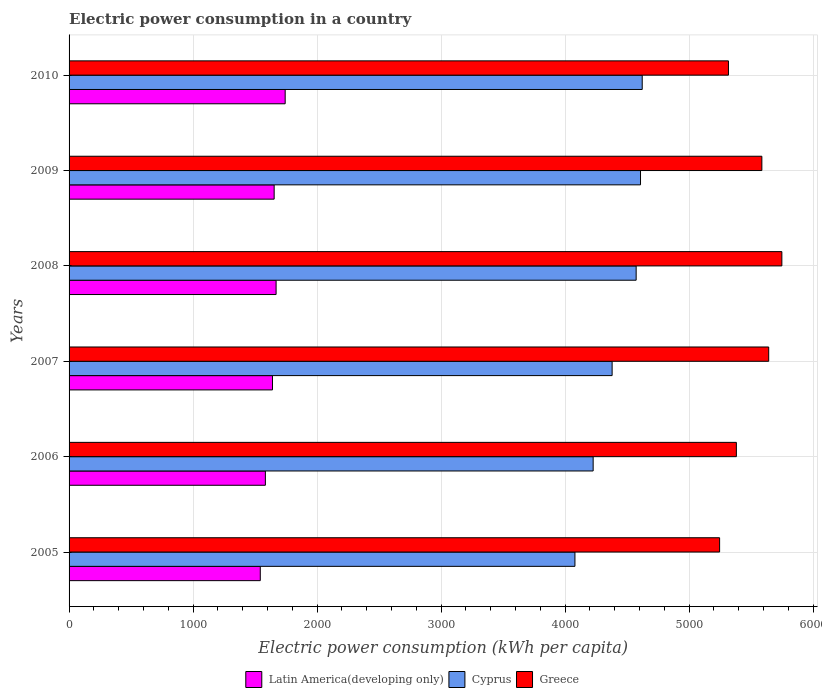How many groups of bars are there?
Your answer should be very brief. 6. Are the number of bars per tick equal to the number of legend labels?
Ensure brevity in your answer.  Yes. How many bars are there on the 5th tick from the top?
Your answer should be compact. 3. How many bars are there on the 6th tick from the bottom?
Give a very brief answer. 3. What is the electric power consumption in in Latin America(developing only) in 2010?
Your response must be concise. 1742.94. Across all years, what is the maximum electric power consumption in in Latin America(developing only)?
Offer a very short reply. 1742.94. Across all years, what is the minimum electric power consumption in in Cyprus?
Your answer should be compact. 4080.05. In which year was the electric power consumption in in Latin America(developing only) minimum?
Provide a succinct answer. 2005. What is the total electric power consumption in in Cyprus in the graph?
Offer a very short reply. 2.65e+04. What is the difference between the electric power consumption in in Latin America(developing only) in 2009 and that in 2010?
Provide a short and direct response. -88.87. What is the difference between the electric power consumption in in Cyprus in 2006 and the electric power consumption in in Greece in 2005?
Provide a short and direct response. -1019.9. What is the average electric power consumption in in Cyprus per year?
Your response must be concise. 4415.37. In the year 2007, what is the difference between the electric power consumption in in Cyprus and electric power consumption in in Latin America(developing only)?
Provide a succinct answer. 2739.26. What is the ratio of the electric power consumption in in Greece in 2007 to that in 2008?
Make the answer very short. 0.98. Is the electric power consumption in in Latin America(developing only) in 2005 less than that in 2006?
Ensure brevity in your answer.  Yes. What is the difference between the highest and the second highest electric power consumption in in Cyprus?
Provide a short and direct response. 13.74. What is the difference between the highest and the lowest electric power consumption in in Cyprus?
Provide a succinct answer. 542.65. In how many years, is the electric power consumption in in Cyprus greater than the average electric power consumption in in Cyprus taken over all years?
Provide a short and direct response. 3. What does the 3rd bar from the top in 2006 represents?
Your response must be concise. Latin America(developing only). What does the 2nd bar from the bottom in 2005 represents?
Provide a short and direct response. Cyprus. Is it the case that in every year, the sum of the electric power consumption in in Latin America(developing only) and electric power consumption in in Cyprus is greater than the electric power consumption in in Greece?
Keep it short and to the point. Yes. How many bars are there?
Provide a succinct answer. 18. Does the graph contain any zero values?
Make the answer very short. No. Does the graph contain grids?
Give a very brief answer. Yes. Where does the legend appear in the graph?
Offer a very short reply. Bottom center. How many legend labels are there?
Offer a very short reply. 3. What is the title of the graph?
Offer a very short reply. Electric power consumption in a country. Does "Lower middle income" appear as one of the legend labels in the graph?
Your answer should be compact. No. What is the label or title of the X-axis?
Ensure brevity in your answer.  Electric power consumption (kWh per capita). What is the label or title of the Y-axis?
Provide a short and direct response. Years. What is the Electric power consumption (kWh per capita) in Latin America(developing only) in 2005?
Provide a succinct answer. 1542.13. What is the Electric power consumption (kWh per capita) in Cyprus in 2005?
Your response must be concise. 4080.05. What is the Electric power consumption (kWh per capita) of Greece in 2005?
Provide a succinct answer. 5246.77. What is the Electric power consumption (kWh per capita) of Latin America(developing only) in 2006?
Keep it short and to the point. 1583.23. What is the Electric power consumption (kWh per capita) in Cyprus in 2006?
Provide a short and direct response. 4226.87. What is the Electric power consumption (kWh per capita) in Greece in 2006?
Provide a short and direct response. 5382.03. What is the Electric power consumption (kWh per capita) of Latin America(developing only) in 2007?
Offer a terse response. 1640.63. What is the Electric power consumption (kWh per capita) in Cyprus in 2007?
Ensure brevity in your answer.  4379.89. What is the Electric power consumption (kWh per capita) of Greece in 2007?
Your answer should be very brief. 5642.84. What is the Electric power consumption (kWh per capita) of Latin America(developing only) in 2008?
Make the answer very short. 1669.76. What is the Electric power consumption (kWh per capita) in Cyprus in 2008?
Your answer should be compact. 4573.77. What is the Electric power consumption (kWh per capita) of Greece in 2008?
Make the answer very short. 5748.84. What is the Electric power consumption (kWh per capita) of Latin America(developing only) in 2009?
Keep it short and to the point. 1654.08. What is the Electric power consumption (kWh per capita) in Cyprus in 2009?
Your response must be concise. 4608.95. What is the Electric power consumption (kWh per capita) of Greece in 2009?
Offer a very short reply. 5587.6. What is the Electric power consumption (kWh per capita) of Latin America(developing only) in 2010?
Offer a very short reply. 1742.94. What is the Electric power consumption (kWh per capita) in Cyprus in 2010?
Provide a short and direct response. 4622.7. What is the Electric power consumption (kWh per capita) of Greece in 2010?
Ensure brevity in your answer.  5318.08. Across all years, what is the maximum Electric power consumption (kWh per capita) of Latin America(developing only)?
Your answer should be very brief. 1742.94. Across all years, what is the maximum Electric power consumption (kWh per capita) in Cyprus?
Provide a short and direct response. 4622.7. Across all years, what is the maximum Electric power consumption (kWh per capita) in Greece?
Offer a terse response. 5748.84. Across all years, what is the minimum Electric power consumption (kWh per capita) in Latin America(developing only)?
Provide a succinct answer. 1542.13. Across all years, what is the minimum Electric power consumption (kWh per capita) in Cyprus?
Make the answer very short. 4080.05. Across all years, what is the minimum Electric power consumption (kWh per capita) in Greece?
Give a very brief answer. 5246.77. What is the total Electric power consumption (kWh per capita) in Latin America(developing only) in the graph?
Your answer should be compact. 9832.77. What is the total Electric power consumption (kWh per capita) in Cyprus in the graph?
Give a very brief answer. 2.65e+04. What is the total Electric power consumption (kWh per capita) in Greece in the graph?
Make the answer very short. 3.29e+04. What is the difference between the Electric power consumption (kWh per capita) in Latin America(developing only) in 2005 and that in 2006?
Provide a succinct answer. -41.1. What is the difference between the Electric power consumption (kWh per capita) of Cyprus in 2005 and that in 2006?
Your answer should be compact. -146.82. What is the difference between the Electric power consumption (kWh per capita) in Greece in 2005 and that in 2006?
Your answer should be very brief. -135.26. What is the difference between the Electric power consumption (kWh per capita) of Latin America(developing only) in 2005 and that in 2007?
Offer a very short reply. -98.51. What is the difference between the Electric power consumption (kWh per capita) of Cyprus in 2005 and that in 2007?
Give a very brief answer. -299.84. What is the difference between the Electric power consumption (kWh per capita) of Greece in 2005 and that in 2007?
Your answer should be compact. -396.06. What is the difference between the Electric power consumption (kWh per capita) of Latin America(developing only) in 2005 and that in 2008?
Ensure brevity in your answer.  -127.63. What is the difference between the Electric power consumption (kWh per capita) of Cyprus in 2005 and that in 2008?
Keep it short and to the point. -493.73. What is the difference between the Electric power consumption (kWh per capita) in Greece in 2005 and that in 2008?
Provide a short and direct response. -502.06. What is the difference between the Electric power consumption (kWh per capita) in Latin America(developing only) in 2005 and that in 2009?
Make the answer very short. -111.95. What is the difference between the Electric power consumption (kWh per capita) of Cyprus in 2005 and that in 2009?
Make the answer very short. -528.91. What is the difference between the Electric power consumption (kWh per capita) in Greece in 2005 and that in 2009?
Provide a succinct answer. -340.83. What is the difference between the Electric power consumption (kWh per capita) of Latin America(developing only) in 2005 and that in 2010?
Your response must be concise. -200.81. What is the difference between the Electric power consumption (kWh per capita) of Cyprus in 2005 and that in 2010?
Your response must be concise. -542.65. What is the difference between the Electric power consumption (kWh per capita) of Greece in 2005 and that in 2010?
Offer a terse response. -71.31. What is the difference between the Electric power consumption (kWh per capita) of Latin America(developing only) in 2006 and that in 2007?
Your answer should be very brief. -57.41. What is the difference between the Electric power consumption (kWh per capita) in Cyprus in 2006 and that in 2007?
Ensure brevity in your answer.  -153.02. What is the difference between the Electric power consumption (kWh per capita) of Greece in 2006 and that in 2007?
Ensure brevity in your answer.  -260.8. What is the difference between the Electric power consumption (kWh per capita) of Latin America(developing only) in 2006 and that in 2008?
Provide a short and direct response. -86.53. What is the difference between the Electric power consumption (kWh per capita) of Cyprus in 2006 and that in 2008?
Provide a short and direct response. -346.9. What is the difference between the Electric power consumption (kWh per capita) in Greece in 2006 and that in 2008?
Ensure brevity in your answer.  -366.8. What is the difference between the Electric power consumption (kWh per capita) in Latin America(developing only) in 2006 and that in 2009?
Keep it short and to the point. -70.85. What is the difference between the Electric power consumption (kWh per capita) of Cyprus in 2006 and that in 2009?
Keep it short and to the point. -382.08. What is the difference between the Electric power consumption (kWh per capita) in Greece in 2006 and that in 2009?
Your answer should be very brief. -205.57. What is the difference between the Electric power consumption (kWh per capita) of Latin America(developing only) in 2006 and that in 2010?
Provide a succinct answer. -159.72. What is the difference between the Electric power consumption (kWh per capita) in Cyprus in 2006 and that in 2010?
Keep it short and to the point. -395.82. What is the difference between the Electric power consumption (kWh per capita) in Greece in 2006 and that in 2010?
Ensure brevity in your answer.  63.95. What is the difference between the Electric power consumption (kWh per capita) of Latin America(developing only) in 2007 and that in 2008?
Your answer should be very brief. -29.12. What is the difference between the Electric power consumption (kWh per capita) of Cyprus in 2007 and that in 2008?
Offer a very short reply. -193.88. What is the difference between the Electric power consumption (kWh per capita) in Greece in 2007 and that in 2008?
Give a very brief answer. -106. What is the difference between the Electric power consumption (kWh per capita) in Latin America(developing only) in 2007 and that in 2009?
Provide a short and direct response. -13.44. What is the difference between the Electric power consumption (kWh per capita) in Cyprus in 2007 and that in 2009?
Your answer should be compact. -229.06. What is the difference between the Electric power consumption (kWh per capita) in Greece in 2007 and that in 2009?
Provide a short and direct response. 55.23. What is the difference between the Electric power consumption (kWh per capita) of Latin America(developing only) in 2007 and that in 2010?
Provide a short and direct response. -102.31. What is the difference between the Electric power consumption (kWh per capita) of Cyprus in 2007 and that in 2010?
Your answer should be compact. -242.8. What is the difference between the Electric power consumption (kWh per capita) of Greece in 2007 and that in 2010?
Provide a short and direct response. 324.75. What is the difference between the Electric power consumption (kWh per capita) in Latin America(developing only) in 2008 and that in 2009?
Provide a succinct answer. 15.68. What is the difference between the Electric power consumption (kWh per capita) of Cyprus in 2008 and that in 2009?
Offer a very short reply. -35.18. What is the difference between the Electric power consumption (kWh per capita) in Greece in 2008 and that in 2009?
Your answer should be compact. 161.23. What is the difference between the Electric power consumption (kWh per capita) in Latin America(developing only) in 2008 and that in 2010?
Provide a succinct answer. -73.18. What is the difference between the Electric power consumption (kWh per capita) in Cyprus in 2008 and that in 2010?
Offer a very short reply. -48.92. What is the difference between the Electric power consumption (kWh per capita) of Greece in 2008 and that in 2010?
Your response must be concise. 430.75. What is the difference between the Electric power consumption (kWh per capita) in Latin America(developing only) in 2009 and that in 2010?
Offer a very short reply. -88.87. What is the difference between the Electric power consumption (kWh per capita) of Cyprus in 2009 and that in 2010?
Provide a short and direct response. -13.74. What is the difference between the Electric power consumption (kWh per capita) in Greece in 2009 and that in 2010?
Your answer should be compact. 269.52. What is the difference between the Electric power consumption (kWh per capita) in Latin America(developing only) in 2005 and the Electric power consumption (kWh per capita) in Cyprus in 2006?
Provide a succinct answer. -2684.74. What is the difference between the Electric power consumption (kWh per capita) in Latin America(developing only) in 2005 and the Electric power consumption (kWh per capita) in Greece in 2006?
Make the answer very short. -3839.91. What is the difference between the Electric power consumption (kWh per capita) in Cyprus in 2005 and the Electric power consumption (kWh per capita) in Greece in 2006?
Your answer should be compact. -1301.99. What is the difference between the Electric power consumption (kWh per capita) of Latin America(developing only) in 2005 and the Electric power consumption (kWh per capita) of Cyprus in 2007?
Offer a very short reply. -2837.76. What is the difference between the Electric power consumption (kWh per capita) in Latin America(developing only) in 2005 and the Electric power consumption (kWh per capita) in Greece in 2007?
Make the answer very short. -4100.71. What is the difference between the Electric power consumption (kWh per capita) in Cyprus in 2005 and the Electric power consumption (kWh per capita) in Greece in 2007?
Offer a terse response. -1562.79. What is the difference between the Electric power consumption (kWh per capita) of Latin America(developing only) in 2005 and the Electric power consumption (kWh per capita) of Cyprus in 2008?
Provide a succinct answer. -3031.64. What is the difference between the Electric power consumption (kWh per capita) of Latin America(developing only) in 2005 and the Electric power consumption (kWh per capita) of Greece in 2008?
Make the answer very short. -4206.71. What is the difference between the Electric power consumption (kWh per capita) of Cyprus in 2005 and the Electric power consumption (kWh per capita) of Greece in 2008?
Provide a succinct answer. -1668.79. What is the difference between the Electric power consumption (kWh per capita) in Latin America(developing only) in 2005 and the Electric power consumption (kWh per capita) in Cyprus in 2009?
Provide a short and direct response. -3066.83. What is the difference between the Electric power consumption (kWh per capita) in Latin America(developing only) in 2005 and the Electric power consumption (kWh per capita) in Greece in 2009?
Provide a short and direct response. -4045.47. What is the difference between the Electric power consumption (kWh per capita) of Cyprus in 2005 and the Electric power consumption (kWh per capita) of Greece in 2009?
Provide a short and direct response. -1507.56. What is the difference between the Electric power consumption (kWh per capita) of Latin America(developing only) in 2005 and the Electric power consumption (kWh per capita) of Cyprus in 2010?
Offer a terse response. -3080.57. What is the difference between the Electric power consumption (kWh per capita) of Latin America(developing only) in 2005 and the Electric power consumption (kWh per capita) of Greece in 2010?
Give a very brief answer. -3775.95. What is the difference between the Electric power consumption (kWh per capita) in Cyprus in 2005 and the Electric power consumption (kWh per capita) in Greece in 2010?
Your response must be concise. -1238.04. What is the difference between the Electric power consumption (kWh per capita) of Latin America(developing only) in 2006 and the Electric power consumption (kWh per capita) of Cyprus in 2007?
Your response must be concise. -2796.67. What is the difference between the Electric power consumption (kWh per capita) of Latin America(developing only) in 2006 and the Electric power consumption (kWh per capita) of Greece in 2007?
Keep it short and to the point. -4059.61. What is the difference between the Electric power consumption (kWh per capita) of Cyprus in 2006 and the Electric power consumption (kWh per capita) of Greece in 2007?
Provide a succinct answer. -1415.97. What is the difference between the Electric power consumption (kWh per capita) of Latin America(developing only) in 2006 and the Electric power consumption (kWh per capita) of Cyprus in 2008?
Offer a terse response. -2990.55. What is the difference between the Electric power consumption (kWh per capita) of Latin America(developing only) in 2006 and the Electric power consumption (kWh per capita) of Greece in 2008?
Give a very brief answer. -4165.61. What is the difference between the Electric power consumption (kWh per capita) of Cyprus in 2006 and the Electric power consumption (kWh per capita) of Greece in 2008?
Offer a very short reply. -1521.96. What is the difference between the Electric power consumption (kWh per capita) in Latin America(developing only) in 2006 and the Electric power consumption (kWh per capita) in Cyprus in 2009?
Keep it short and to the point. -3025.73. What is the difference between the Electric power consumption (kWh per capita) of Latin America(developing only) in 2006 and the Electric power consumption (kWh per capita) of Greece in 2009?
Make the answer very short. -4004.38. What is the difference between the Electric power consumption (kWh per capita) in Cyprus in 2006 and the Electric power consumption (kWh per capita) in Greece in 2009?
Your answer should be compact. -1360.73. What is the difference between the Electric power consumption (kWh per capita) in Latin America(developing only) in 2006 and the Electric power consumption (kWh per capita) in Cyprus in 2010?
Keep it short and to the point. -3039.47. What is the difference between the Electric power consumption (kWh per capita) in Latin America(developing only) in 2006 and the Electric power consumption (kWh per capita) in Greece in 2010?
Offer a terse response. -3734.86. What is the difference between the Electric power consumption (kWh per capita) in Cyprus in 2006 and the Electric power consumption (kWh per capita) in Greece in 2010?
Your answer should be very brief. -1091.21. What is the difference between the Electric power consumption (kWh per capita) of Latin America(developing only) in 2007 and the Electric power consumption (kWh per capita) of Cyprus in 2008?
Ensure brevity in your answer.  -2933.14. What is the difference between the Electric power consumption (kWh per capita) of Latin America(developing only) in 2007 and the Electric power consumption (kWh per capita) of Greece in 2008?
Offer a terse response. -4108.2. What is the difference between the Electric power consumption (kWh per capita) of Cyprus in 2007 and the Electric power consumption (kWh per capita) of Greece in 2008?
Your response must be concise. -1368.94. What is the difference between the Electric power consumption (kWh per capita) of Latin America(developing only) in 2007 and the Electric power consumption (kWh per capita) of Cyprus in 2009?
Ensure brevity in your answer.  -2968.32. What is the difference between the Electric power consumption (kWh per capita) in Latin America(developing only) in 2007 and the Electric power consumption (kWh per capita) in Greece in 2009?
Make the answer very short. -3946.97. What is the difference between the Electric power consumption (kWh per capita) in Cyprus in 2007 and the Electric power consumption (kWh per capita) in Greece in 2009?
Your answer should be very brief. -1207.71. What is the difference between the Electric power consumption (kWh per capita) in Latin America(developing only) in 2007 and the Electric power consumption (kWh per capita) in Cyprus in 2010?
Keep it short and to the point. -2982.06. What is the difference between the Electric power consumption (kWh per capita) of Latin America(developing only) in 2007 and the Electric power consumption (kWh per capita) of Greece in 2010?
Offer a very short reply. -3677.45. What is the difference between the Electric power consumption (kWh per capita) of Cyprus in 2007 and the Electric power consumption (kWh per capita) of Greece in 2010?
Provide a succinct answer. -938.19. What is the difference between the Electric power consumption (kWh per capita) of Latin America(developing only) in 2008 and the Electric power consumption (kWh per capita) of Cyprus in 2009?
Offer a very short reply. -2939.2. What is the difference between the Electric power consumption (kWh per capita) in Latin America(developing only) in 2008 and the Electric power consumption (kWh per capita) in Greece in 2009?
Your response must be concise. -3917.85. What is the difference between the Electric power consumption (kWh per capita) in Cyprus in 2008 and the Electric power consumption (kWh per capita) in Greece in 2009?
Offer a terse response. -1013.83. What is the difference between the Electric power consumption (kWh per capita) in Latin America(developing only) in 2008 and the Electric power consumption (kWh per capita) in Cyprus in 2010?
Provide a short and direct response. -2952.94. What is the difference between the Electric power consumption (kWh per capita) in Latin America(developing only) in 2008 and the Electric power consumption (kWh per capita) in Greece in 2010?
Offer a very short reply. -3648.33. What is the difference between the Electric power consumption (kWh per capita) in Cyprus in 2008 and the Electric power consumption (kWh per capita) in Greece in 2010?
Offer a very short reply. -744.31. What is the difference between the Electric power consumption (kWh per capita) of Latin America(developing only) in 2009 and the Electric power consumption (kWh per capita) of Cyprus in 2010?
Provide a short and direct response. -2968.62. What is the difference between the Electric power consumption (kWh per capita) of Latin America(developing only) in 2009 and the Electric power consumption (kWh per capita) of Greece in 2010?
Offer a very short reply. -3664.01. What is the difference between the Electric power consumption (kWh per capita) in Cyprus in 2009 and the Electric power consumption (kWh per capita) in Greece in 2010?
Your answer should be compact. -709.13. What is the average Electric power consumption (kWh per capita) of Latin America(developing only) per year?
Offer a terse response. 1638.79. What is the average Electric power consumption (kWh per capita) in Cyprus per year?
Your answer should be compact. 4415.37. What is the average Electric power consumption (kWh per capita) of Greece per year?
Your answer should be compact. 5487.69. In the year 2005, what is the difference between the Electric power consumption (kWh per capita) in Latin America(developing only) and Electric power consumption (kWh per capita) in Cyprus?
Ensure brevity in your answer.  -2537.92. In the year 2005, what is the difference between the Electric power consumption (kWh per capita) in Latin America(developing only) and Electric power consumption (kWh per capita) in Greece?
Offer a terse response. -3704.64. In the year 2005, what is the difference between the Electric power consumption (kWh per capita) in Cyprus and Electric power consumption (kWh per capita) in Greece?
Offer a terse response. -1166.73. In the year 2006, what is the difference between the Electric power consumption (kWh per capita) in Latin America(developing only) and Electric power consumption (kWh per capita) in Cyprus?
Ensure brevity in your answer.  -2643.65. In the year 2006, what is the difference between the Electric power consumption (kWh per capita) in Latin America(developing only) and Electric power consumption (kWh per capita) in Greece?
Your response must be concise. -3798.81. In the year 2006, what is the difference between the Electric power consumption (kWh per capita) of Cyprus and Electric power consumption (kWh per capita) of Greece?
Your response must be concise. -1155.16. In the year 2007, what is the difference between the Electric power consumption (kWh per capita) of Latin America(developing only) and Electric power consumption (kWh per capita) of Cyprus?
Ensure brevity in your answer.  -2739.26. In the year 2007, what is the difference between the Electric power consumption (kWh per capita) of Latin America(developing only) and Electric power consumption (kWh per capita) of Greece?
Your response must be concise. -4002.2. In the year 2007, what is the difference between the Electric power consumption (kWh per capita) of Cyprus and Electric power consumption (kWh per capita) of Greece?
Your response must be concise. -1262.95. In the year 2008, what is the difference between the Electric power consumption (kWh per capita) of Latin America(developing only) and Electric power consumption (kWh per capita) of Cyprus?
Keep it short and to the point. -2904.02. In the year 2008, what is the difference between the Electric power consumption (kWh per capita) of Latin America(developing only) and Electric power consumption (kWh per capita) of Greece?
Your response must be concise. -4079.08. In the year 2008, what is the difference between the Electric power consumption (kWh per capita) of Cyprus and Electric power consumption (kWh per capita) of Greece?
Your response must be concise. -1175.06. In the year 2009, what is the difference between the Electric power consumption (kWh per capita) in Latin America(developing only) and Electric power consumption (kWh per capita) in Cyprus?
Your answer should be very brief. -2954.88. In the year 2009, what is the difference between the Electric power consumption (kWh per capita) of Latin America(developing only) and Electric power consumption (kWh per capita) of Greece?
Give a very brief answer. -3933.53. In the year 2009, what is the difference between the Electric power consumption (kWh per capita) of Cyprus and Electric power consumption (kWh per capita) of Greece?
Provide a succinct answer. -978.65. In the year 2010, what is the difference between the Electric power consumption (kWh per capita) in Latin America(developing only) and Electric power consumption (kWh per capita) in Cyprus?
Your answer should be compact. -2879.75. In the year 2010, what is the difference between the Electric power consumption (kWh per capita) in Latin America(developing only) and Electric power consumption (kWh per capita) in Greece?
Your response must be concise. -3575.14. In the year 2010, what is the difference between the Electric power consumption (kWh per capita) of Cyprus and Electric power consumption (kWh per capita) of Greece?
Offer a very short reply. -695.39. What is the ratio of the Electric power consumption (kWh per capita) of Cyprus in 2005 to that in 2006?
Make the answer very short. 0.97. What is the ratio of the Electric power consumption (kWh per capita) of Greece in 2005 to that in 2006?
Offer a very short reply. 0.97. What is the ratio of the Electric power consumption (kWh per capita) of Cyprus in 2005 to that in 2007?
Offer a very short reply. 0.93. What is the ratio of the Electric power consumption (kWh per capita) in Greece in 2005 to that in 2007?
Provide a succinct answer. 0.93. What is the ratio of the Electric power consumption (kWh per capita) in Latin America(developing only) in 2005 to that in 2008?
Provide a succinct answer. 0.92. What is the ratio of the Electric power consumption (kWh per capita) in Cyprus in 2005 to that in 2008?
Ensure brevity in your answer.  0.89. What is the ratio of the Electric power consumption (kWh per capita) in Greece in 2005 to that in 2008?
Provide a short and direct response. 0.91. What is the ratio of the Electric power consumption (kWh per capita) in Latin America(developing only) in 2005 to that in 2009?
Provide a succinct answer. 0.93. What is the ratio of the Electric power consumption (kWh per capita) in Cyprus in 2005 to that in 2009?
Provide a short and direct response. 0.89. What is the ratio of the Electric power consumption (kWh per capita) in Greece in 2005 to that in 2009?
Your response must be concise. 0.94. What is the ratio of the Electric power consumption (kWh per capita) in Latin America(developing only) in 2005 to that in 2010?
Provide a succinct answer. 0.88. What is the ratio of the Electric power consumption (kWh per capita) in Cyprus in 2005 to that in 2010?
Offer a terse response. 0.88. What is the ratio of the Electric power consumption (kWh per capita) in Greece in 2005 to that in 2010?
Your answer should be compact. 0.99. What is the ratio of the Electric power consumption (kWh per capita) of Latin America(developing only) in 2006 to that in 2007?
Provide a succinct answer. 0.96. What is the ratio of the Electric power consumption (kWh per capita) in Cyprus in 2006 to that in 2007?
Ensure brevity in your answer.  0.97. What is the ratio of the Electric power consumption (kWh per capita) of Greece in 2006 to that in 2007?
Offer a terse response. 0.95. What is the ratio of the Electric power consumption (kWh per capita) of Latin America(developing only) in 2006 to that in 2008?
Your answer should be very brief. 0.95. What is the ratio of the Electric power consumption (kWh per capita) of Cyprus in 2006 to that in 2008?
Your answer should be very brief. 0.92. What is the ratio of the Electric power consumption (kWh per capita) of Greece in 2006 to that in 2008?
Provide a succinct answer. 0.94. What is the ratio of the Electric power consumption (kWh per capita) in Latin America(developing only) in 2006 to that in 2009?
Your answer should be very brief. 0.96. What is the ratio of the Electric power consumption (kWh per capita) of Cyprus in 2006 to that in 2009?
Offer a very short reply. 0.92. What is the ratio of the Electric power consumption (kWh per capita) of Greece in 2006 to that in 2009?
Make the answer very short. 0.96. What is the ratio of the Electric power consumption (kWh per capita) in Latin America(developing only) in 2006 to that in 2010?
Offer a very short reply. 0.91. What is the ratio of the Electric power consumption (kWh per capita) in Cyprus in 2006 to that in 2010?
Offer a very short reply. 0.91. What is the ratio of the Electric power consumption (kWh per capita) of Latin America(developing only) in 2007 to that in 2008?
Keep it short and to the point. 0.98. What is the ratio of the Electric power consumption (kWh per capita) of Cyprus in 2007 to that in 2008?
Your answer should be compact. 0.96. What is the ratio of the Electric power consumption (kWh per capita) in Greece in 2007 to that in 2008?
Give a very brief answer. 0.98. What is the ratio of the Electric power consumption (kWh per capita) of Latin America(developing only) in 2007 to that in 2009?
Provide a succinct answer. 0.99. What is the ratio of the Electric power consumption (kWh per capita) of Cyprus in 2007 to that in 2009?
Give a very brief answer. 0.95. What is the ratio of the Electric power consumption (kWh per capita) in Greece in 2007 to that in 2009?
Ensure brevity in your answer.  1.01. What is the ratio of the Electric power consumption (kWh per capita) in Latin America(developing only) in 2007 to that in 2010?
Keep it short and to the point. 0.94. What is the ratio of the Electric power consumption (kWh per capita) in Cyprus in 2007 to that in 2010?
Provide a succinct answer. 0.95. What is the ratio of the Electric power consumption (kWh per capita) in Greece in 2007 to that in 2010?
Ensure brevity in your answer.  1.06. What is the ratio of the Electric power consumption (kWh per capita) of Latin America(developing only) in 2008 to that in 2009?
Offer a very short reply. 1.01. What is the ratio of the Electric power consumption (kWh per capita) in Greece in 2008 to that in 2009?
Keep it short and to the point. 1.03. What is the ratio of the Electric power consumption (kWh per capita) of Latin America(developing only) in 2008 to that in 2010?
Your answer should be compact. 0.96. What is the ratio of the Electric power consumption (kWh per capita) in Greece in 2008 to that in 2010?
Provide a short and direct response. 1.08. What is the ratio of the Electric power consumption (kWh per capita) in Latin America(developing only) in 2009 to that in 2010?
Ensure brevity in your answer.  0.95. What is the ratio of the Electric power consumption (kWh per capita) in Greece in 2009 to that in 2010?
Your answer should be very brief. 1.05. What is the difference between the highest and the second highest Electric power consumption (kWh per capita) in Latin America(developing only)?
Your answer should be very brief. 73.18. What is the difference between the highest and the second highest Electric power consumption (kWh per capita) in Cyprus?
Ensure brevity in your answer.  13.74. What is the difference between the highest and the second highest Electric power consumption (kWh per capita) of Greece?
Ensure brevity in your answer.  106. What is the difference between the highest and the lowest Electric power consumption (kWh per capita) of Latin America(developing only)?
Offer a terse response. 200.81. What is the difference between the highest and the lowest Electric power consumption (kWh per capita) of Cyprus?
Offer a very short reply. 542.65. What is the difference between the highest and the lowest Electric power consumption (kWh per capita) of Greece?
Provide a succinct answer. 502.06. 